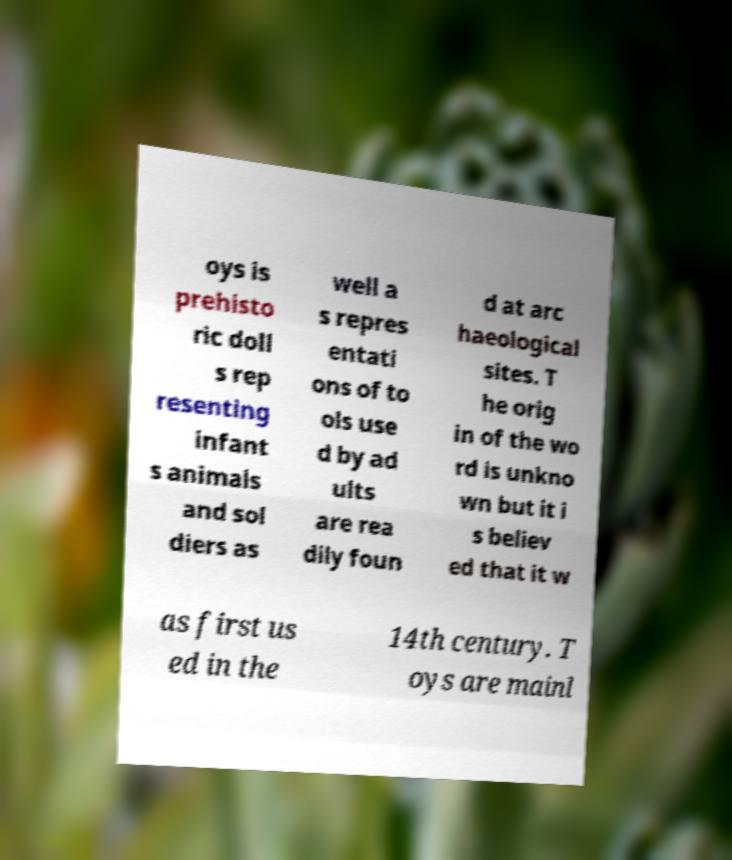Please identify and transcribe the text found in this image. oys is prehisto ric doll s rep resenting infant s animals and sol diers as well a s repres entati ons of to ols use d by ad ults are rea dily foun d at arc haeological sites. T he orig in of the wo rd is unkno wn but it i s believ ed that it w as first us ed in the 14th century. T oys are mainl 